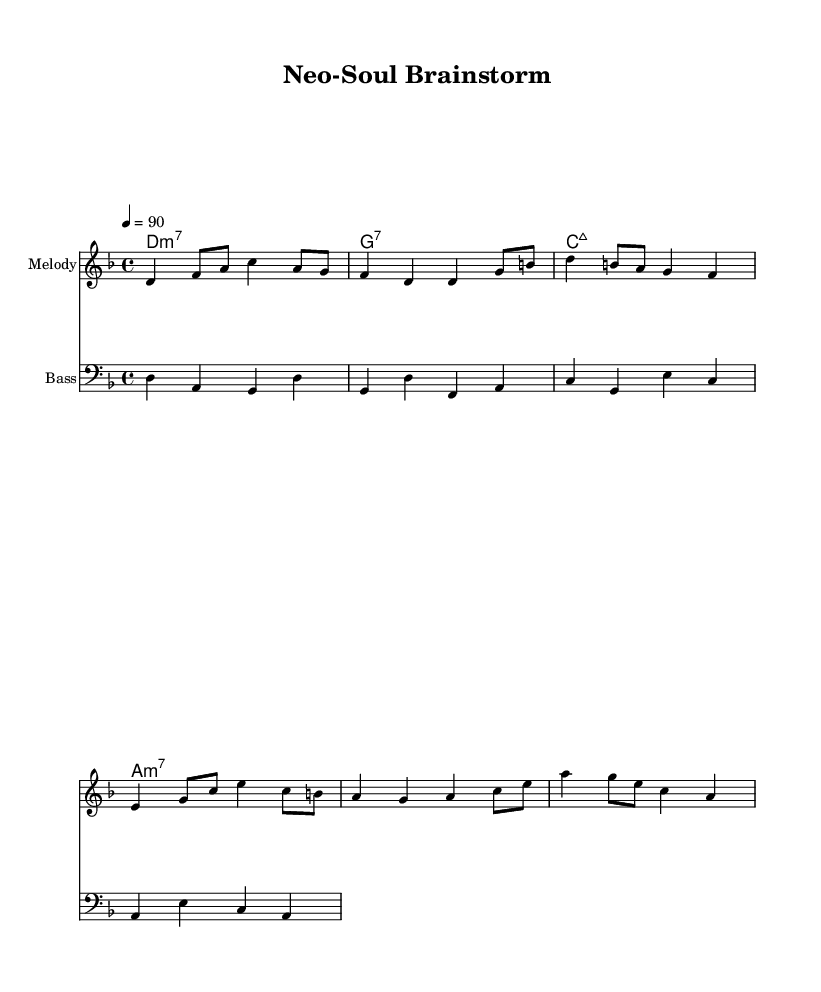What is the key signature of this music? The key signature is indicated by the sharp or flat symbols at the beginning of the staff. In this case, there are no accidentals showing up, indicating a key signature of D minor, which is the relative minor of F major.
Answer: D minor What is the time signature of this music? The time signature is located at the beginning of the staff next to the key signature. Here, it indicates that there are 4 beats in each measure and the quarter note gets one beat.
Answer: 4/4 What is the tempo marking for this piece? The tempo marking is indicated in the score where it says "4 = 90". This means there are 90 quarter note beats per minute, dictating the speed of the piece.
Answer: 90 How many measures are in the melody? To find the number of measures, we count the separate groups of beats in the melody line, each separated by a vertical line. In the provided melody, there are eight measures present.
Answer: 8 What type of chord is indicated on the first measure? The chord type is written above the staff under the "ChordNames" context. The first measure shows "d1:m7," which means it is a D minor 7 chord.
Answer: D minor 7 In what musical style is this piece categorized? The sheet music's title, "Neo-Soul Brainstorm," indicates the style of music. Given that neo-soul incorporates smooth melodies typically found in rhythm and blues, the piece can be categorized under this genre.
Answer: Rhythm and blues What is the highest pitch note in the melody? The highest note can be identified by looking at the melody staff and finding the note that is positioned the highest vertically. The highest note in this melody is C, appearing in the third measure.
Answer: C 